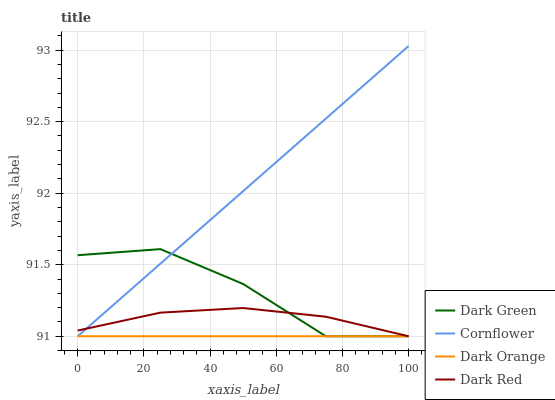Does Dark Red have the minimum area under the curve?
Answer yes or no. No. Does Dark Red have the maximum area under the curve?
Answer yes or no. No. Is Cornflower the smoothest?
Answer yes or no. No. Is Cornflower the roughest?
Answer yes or no. No. Does Dark Red have the highest value?
Answer yes or no. No. 